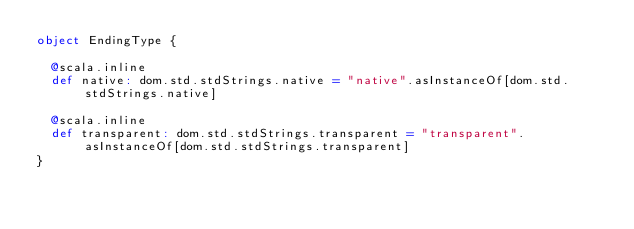Convert code to text. <code><loc_0><loc_0><loc_500><loc_500><_Scala_>object EndingType {
  
  @scala.inline
  def native: dom.std.stdStrings.native = "native".asInstanceOf[dom.std.stdStrings.native]
  
  @scala.inline
  def transparent: dom.std.stdStrings.transparent = "transparent".asInstanceOf[dom.std.stdStrings.transparent]
}
</code> 